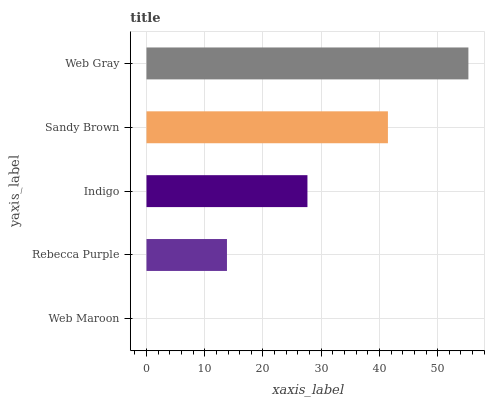Is Web Maroon the minimum?
Answer yes or no. Yes. Is Web Gray the maximum?
Answer yes or no. Yes. Is Rebecca Purple the minimum?
Answer yes or no. No. Is Rebecca Purple the maximum?
Answer yes or no. No. Is Rebecca Purple greater than Web Maroon?
Answer yes or no. Yes. Is Web Maroon less than Rebecca Purple?
Answer yes or no. Yes. Is Web Maroon greater than Rebecca Purple?
Answer yes or no. No. Is Rebecca Purple less than Web Maroon?
Answer yes or no. No. Is Indigo the high median?
Answer yes or no. Yes. Is Indigo the low median?
Answer yes or no. Yes. Is Sandy Brown the high median?
Answer yes or no. No. Is Rebecca Purple the low median?
Answer yes or no. No. 